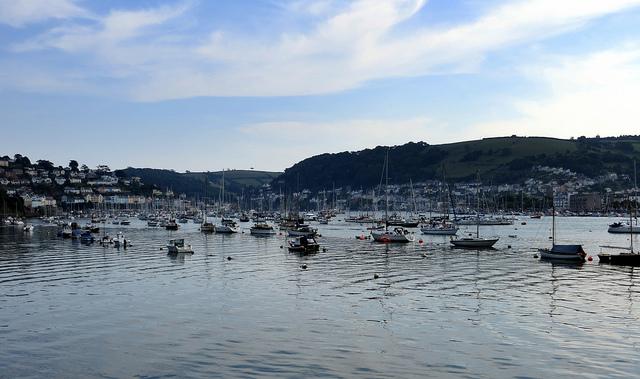What is the boat tied to?
Give a very brief answer. Dock. What buildings are in the background?
Concise answer only. Houses. Is the waterway crowded?
Answer briefly. Yes. Are there houses in the picture?
Answer briefly. Yes. Is this time of day sunset?
Write a very short answer. No. Could this be a marina?
Give a very brief answer. Yes. Does this boat have an engine?
Give a very brief answer. Yes. Is this a foggy day?
Keep it brief. No. What would you call this type of boat parking area?
Quick response, please. Harbor. Does the water seem shallow or deep?
Keep it brief. Deep. Is the image in black and white?
Give a very brief answer. No. How many boats are there?
Concise answer only. Many. Is it morning?
Short answer required. Yes. Is it a cloudy day?
Answer briefly. Yes. Are there any boats?
Quick response, please. Yes. How many boats are in the water?
Keep it brief. 20. Is it overcast?
Short answer required. No. Is there a volcano?
Short answer required. No. Are there any boats on the water?
Answer briefly. Yes. Is the scene a bright day?
Quick response, please. No. Are ducks swimming in the water?
Write a very short answer. No. How many boats are on the water?
Give a very brief answer. 40. Are the boats lined up?
Keep it brief. Yes. What marina are the boats at?
Short answer required. Greece. Is the water full of waves?
Concise answer only. No. 